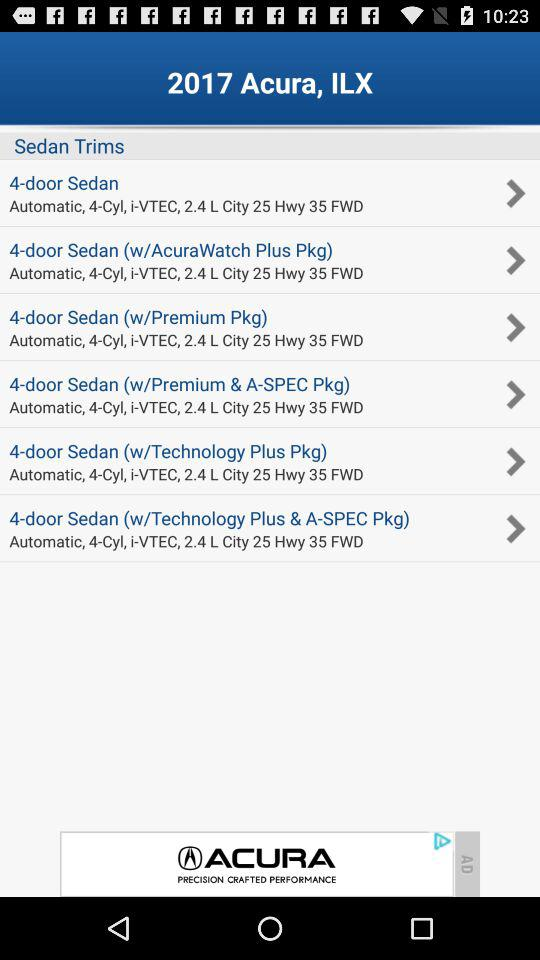How many trims of the 2017 Acura, ILX have an automatic transmission?
Answer the question using a single word or phrase. 6 